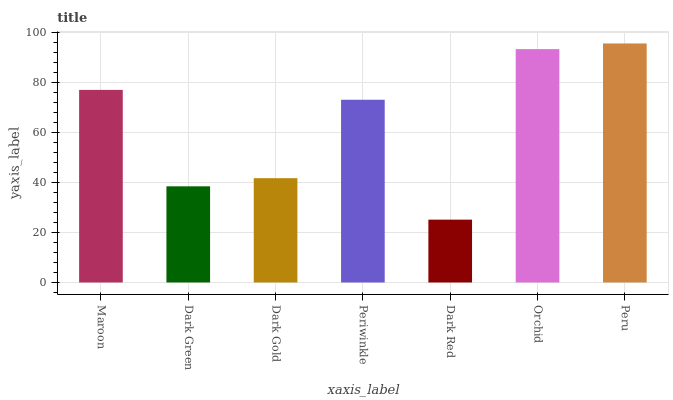Is Dark Red the minimum?
Answer yes or no. Yes. Is Peru the maximum?
Answer yes or no. Yes. Is Dark Green the minimum?
Answer yes or no. No. Is Dark Green the maximum?
Answer yes or no. No. Is Maroon greater than Dark Green?
Answer yes or no. Yes. Is Dark Green less than Maroon?
Answer yes or no. Yes. Is Dark Green greater than Maroon?
Answer yes or no. No. Is Maroon less than Dark Green?
Answer yes or no. No. Is Periwinkle the high median?
Answer yes or no. Yes. Is Periwinkle the low median?
Answer yes or no. Yes. Is Dark Red the high median?
Answer yes or no. No. Is Dark Gold the low median?
Answer yes or no. No. 